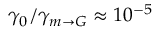Convert formula to latex. <formula><loc_0><loc_0><loc_500><loc_500>\gamma _ { 0 } / \gamma _ { m \rightarrow G } \approx 1 0 ^ { - 5 }</formula> 